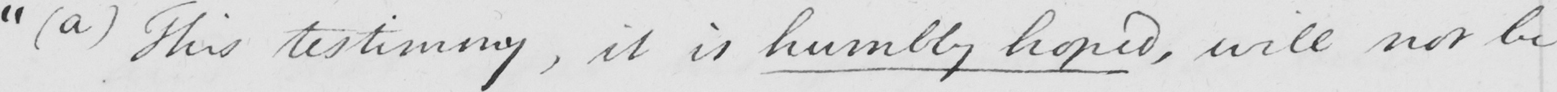Please provide the text content of this handwritten line. "  ( a )  This testimony , it is humbly hoped , will not be 